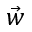Convert formula to latex. <formula><loc_0><loc_0><loc_500><loc_500>\vec { w }</formula> 